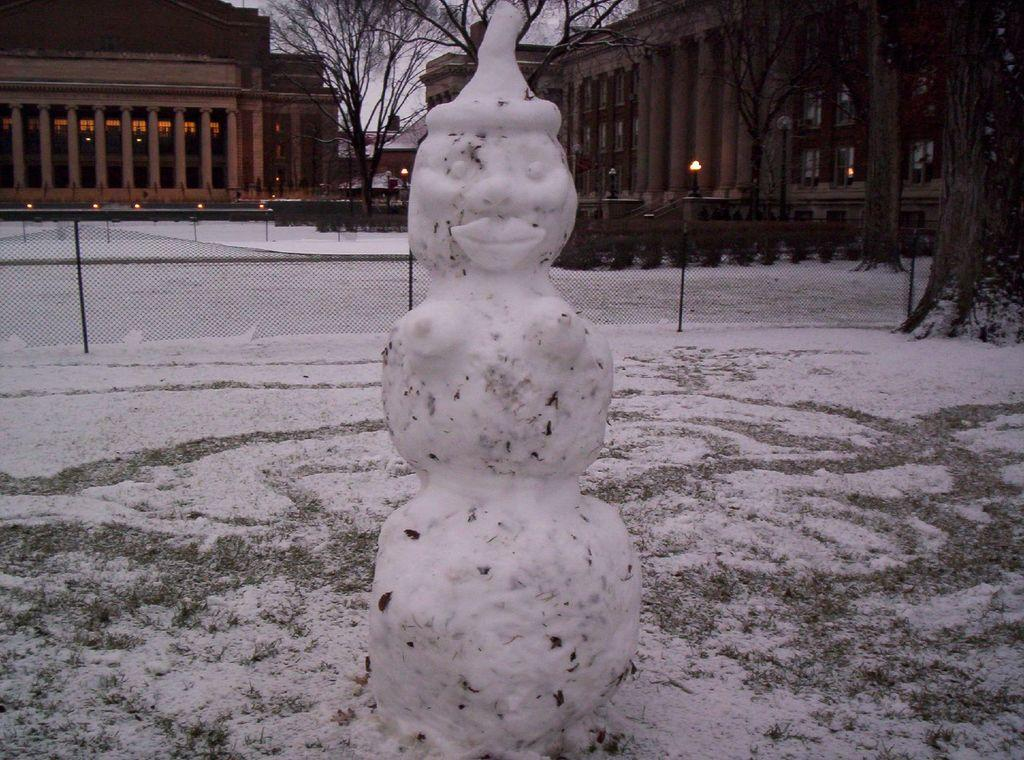What is the main subject of the picture? There is a snowman in the picture. What can be seen in the background of the picture? In the background of the picture, there is a fence, buildings, trees, poles, and other objects on the ground. What is the condition of the ground in the picture? The ground is covered in snow. What type of competition is taking place in the snowy field at night in the image? There is no competition or field present in the image, nor is it nighttime. The image features a snowman with a snow-covered ground and various objects in the background. 